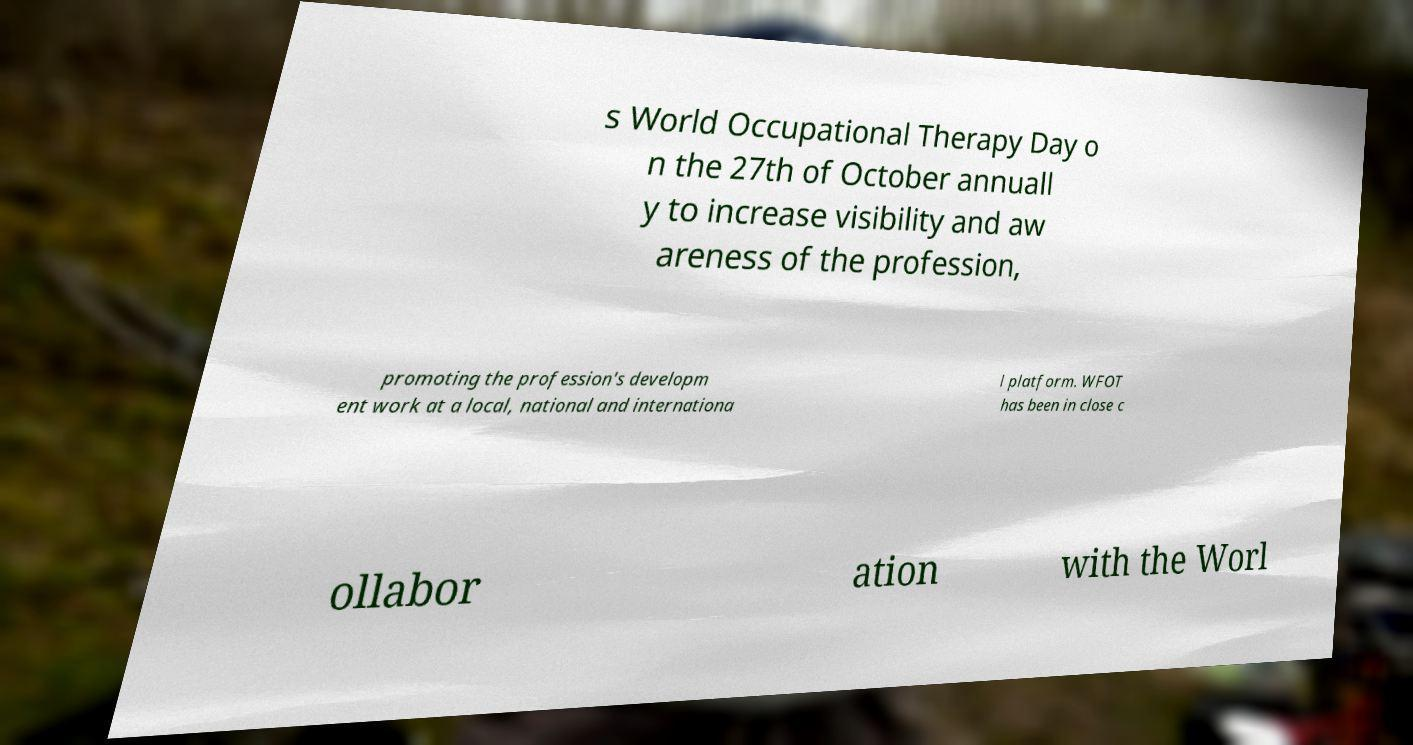What messages or text are displayed in this image? I need them in a readable, typed format. s World Occupational Therapy Day o n the 27th of October annuall y to increase visibility and aw areness of the profession, promoting the profession's developm ent work at a local, national and internationa l platform. WFOT has been in close c ollabor ation with the Worl 